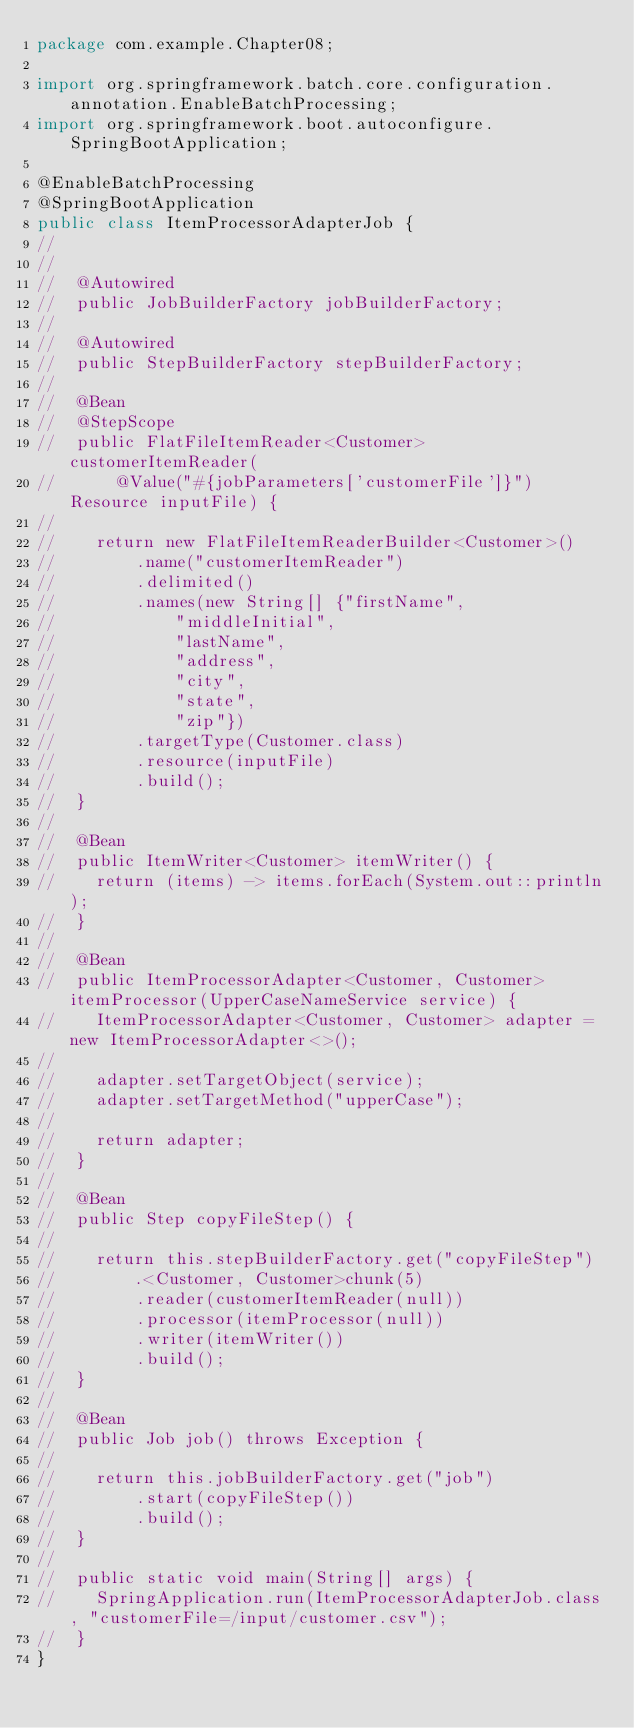<code> <loc_0><loc_0><loc_500><loc_500><_Java_>package com.example.Chapter08;

import org.springframework.batch.core.configuration.annotation.EnableBatchProcessing;
import org.springframework.boot.autoconfigure.SpringBootApplication;

@EnableBatchProcessing
@SpringBootApplication
public class ItemProcessorAdapterJob {
//
//
//	@Autowired
//	public JobBuilderFactory jobBuilderFactory;
//
//	@Autowired
//	public StepBuilderFactory stepBuilderFactory;
//
//	@Bean
//	@StepScope
//	public FlatFileItemReader<Customer> customerItemReader(
//			@Value("#{jobParameters['customerFile']}")Resource inputFile) {
//
//		return new FlatFileItemReaderBuilder<Customer>()
//				.name("customerItemReader")
//				.delimited()
//				.names(new String[] {"firstName",
//						"middleInitial",
//						"lastName",
//						"address",
//						"city",
//						"state",
//						"zip"})
//				.targetType(Customer.class)
//				.resource(inputFile)
//				.build();
//	}
//
//	@Bean
//	public ItemWriter<Customer> itemWriter() {
//		return (items) -> items.forEach(System.out::println);
//	}
//
//	@Bean
//	public ItemProcessorAdapter<Customer, Customer> itemProcessor(UpperCaseNameService service) {
//		ItemProcessorAdapter<Customer, Customer> adapter = new ItemProcessorAdapter<>();
//
//		adapter.setTargetObject(service);
//		adapter.setTargetMethod("upperCase");
//
//		return adapter;
//	}
//
//	@Bean
//	public Step copyFileStep() {
//
//		return this.stepBuilderFactory.get("copyFileStep")
//				.<Customer, Customer>chunk(5)
//				.reader(customerItemReader(null))
//				.processor(itemProcessor(null))
//				.writer(itemWriter())
//				.build();
//	}
//
//	@Bean
//	public Job job() throws Exception {
//
//		return this.jobBuilderFactory.get("job")
//				.start(copyFileStep())
//				.build();
//	}
//
//	public static void main(String[] args) {
//		SpringApplication.run(ItemProcessorAdapterJob.class, "customerFile=/input/customer.csv");
//	}
}

</code> 